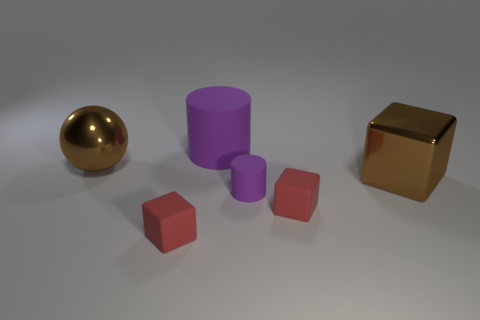Add 4 small blue matte cylinders. How many objects exist? 10 Subtract all cylinders. How many objects are left? 4 Add 1 brown shiny balls. How many brown shiny balls are left? 2 Add 5 big shiny spheres. How many big shiny spheres exist? 6 Subtract 0 red cylinders. How many objects are left? 6 Subtract all brown spheres. Subtract all large brown metallic blocks. How many objects are left? 4 